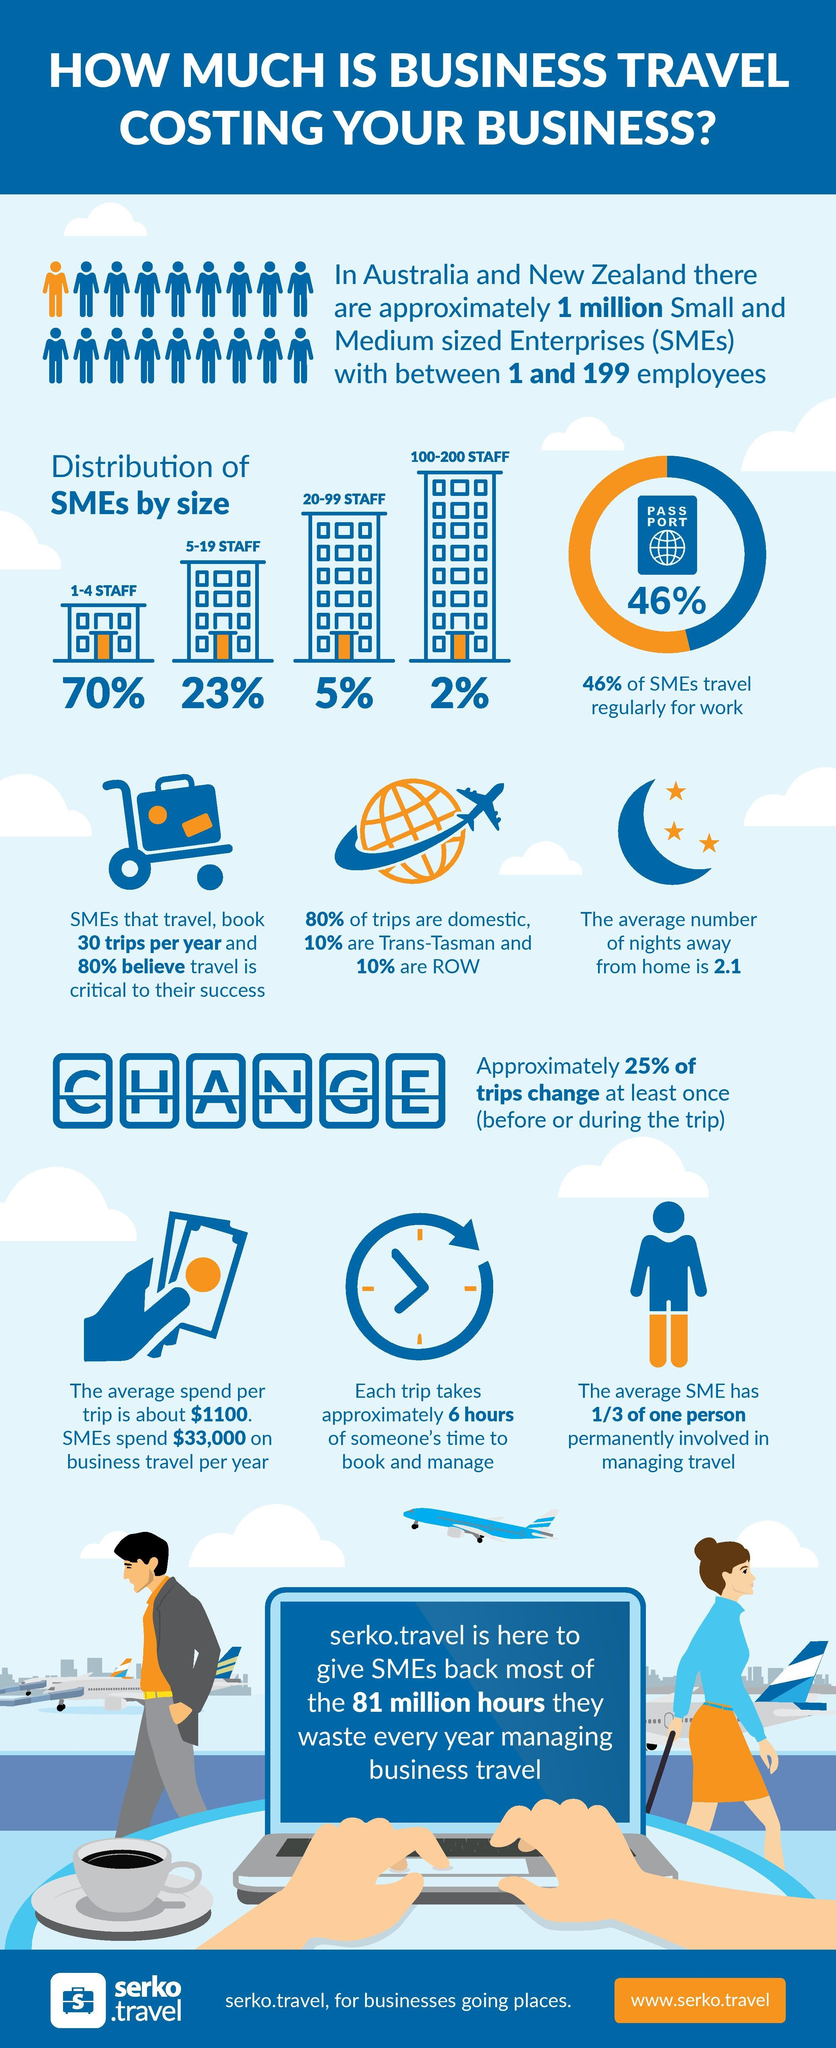Identify some key points in this picture. The infographic features only one woman. According to the data, a significant majority of SMEs (small and medium-sized enterprises) have staffing levels ranging from 1 to 19 employees, with 93% of SMEs falling into this category. The man wears an orange shirt. According to a recent survey, 54% of SMEs do not have to travel regularly. 